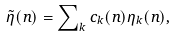Convert formula to latex. <formula><loc_0><loc_0><loc_500><loc_500>\tilde { \eta } ( n ) = \sum \nolimits _ { k } c _ { k } ( n ) \eta _ { k } ( n ) ,</formula> 